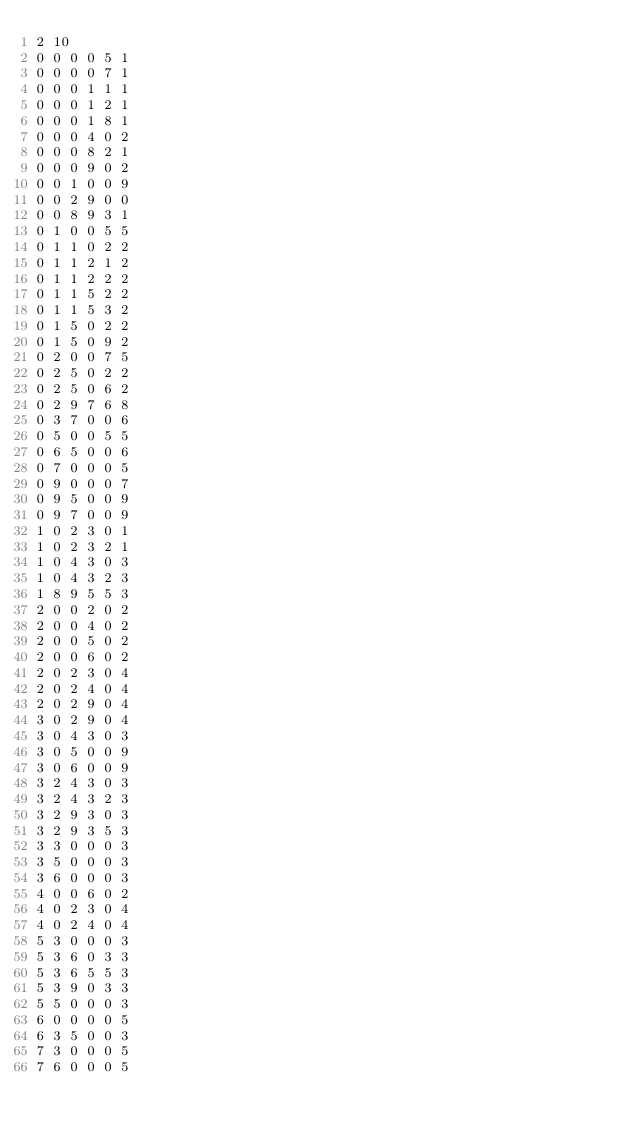Convert code to text. <code><loc_0><loc_0><loc_500><loc_500><_SQL_>2 10
0 0 0 0 5 1
0 0 0 0 7 1
0 0 0 1 1 1
0 0 0 1 2 1
0 0 0 1 8 1
0 0 0 4 0 2
0 0 0 8 2 1
0 0 0 9 0 2
0 0 1 0 0 9
0 0 2 9 0 0
0 0 8 9 3 1
0 1 0 0 5 5
0 1 1 0 2 2
0 1 1 2 1 2
0 1 1 2 2 2
0 1 1 5 2 2
0 1 1 5 3 2
0 1 5 0 2 2
0 1 5 0 9 2
0 2 0 0 7 5
0 2 5 0 2 2
0 2 5 0 6 2
0 2 9 7 6 8
0 3 7 0 0 6
0 5 0 0 5 5
0 6 5 0 0 6
0 7 0 0 0 5
0 9 0 0 0 7
0 9 5 0 0 9
0 9 7 0 0 9
1 0 2 3 0 1
1 0 2 3 2 1
1 0 4 3 0 3
1 0 4 3 2 3
1 8 9 5 5 3
2 0 0 2 0 2
2 0 0 4 0 2
2 0 0 5 0 2
2 0 0 6 0 2
2 0 2 3 0 4
2 0 2 4 0 4
2 0 2 9 0 4
3 0 2 9 0 4
3 0 4 3 0 3
3 0 5 0 0 9
3 0 6 0 0 9
3 2 4 3 0 3
3 2 4 3 2 3
3 2 9 3 0 3
3 2 9 3 5 3
3 3 0 0 0 3
3 5 0 0 0 3
3 6 0 0 0 3
4 0 0 6 0 2
4 0 2 3 0 4
4 0 2 4 0 4
5 3 0 0 0 3
5 3 6 0 3 3
5 3 6 5 5 3
5 3 9 0 3 3
5 5 0 0 0 3
6 0 0 0 0 5
6 3 5 0 0 3
7 3 0 0 0 5
7 6 0 0 0 5</code> 